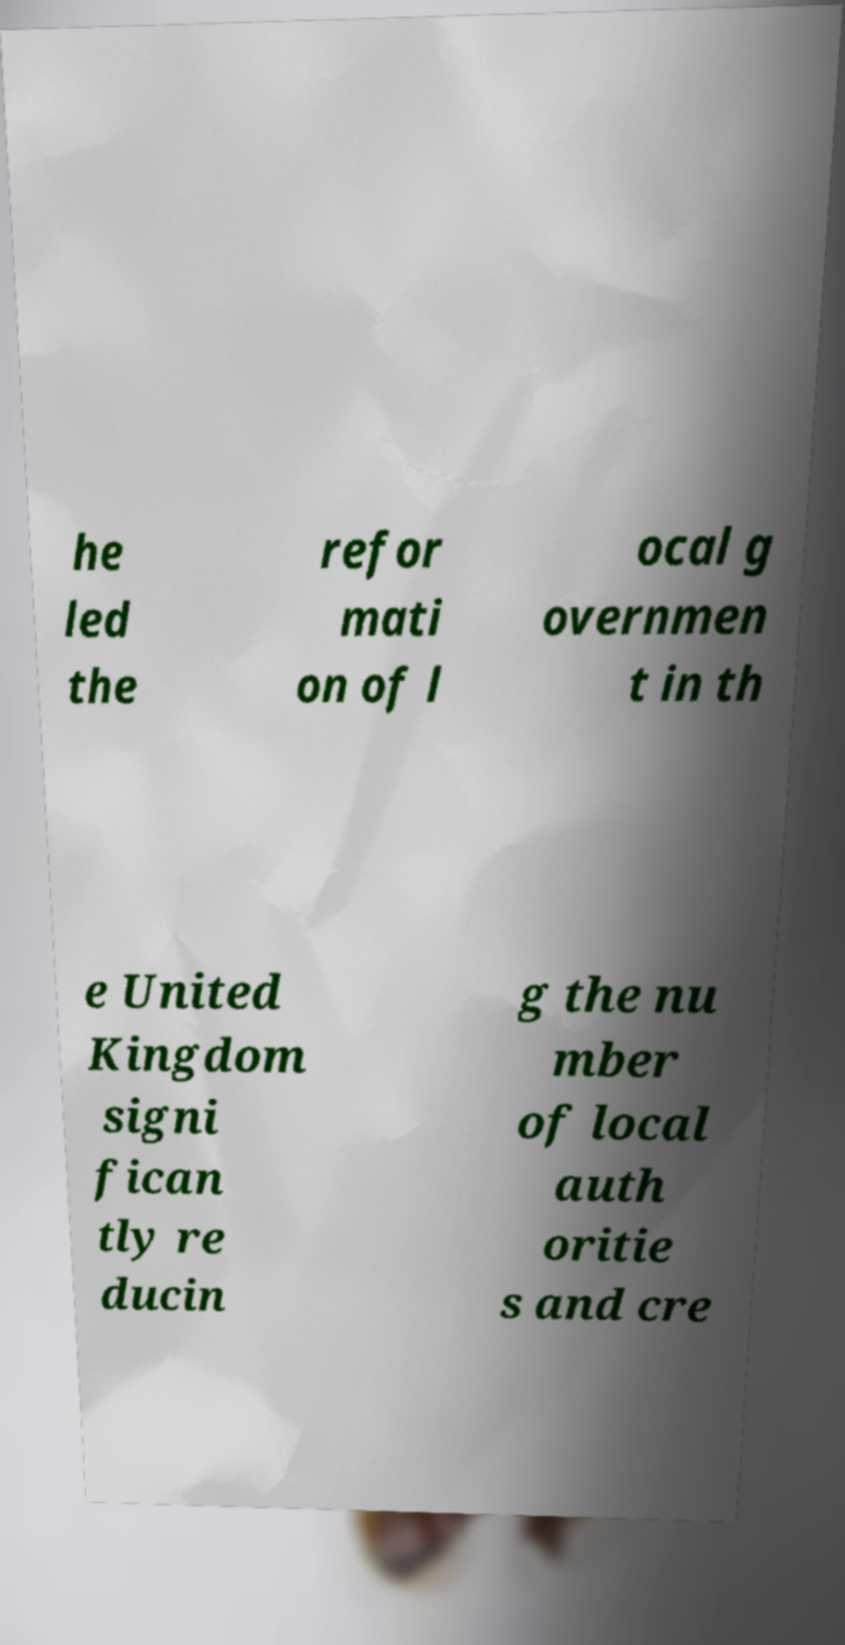I need the written content from this picture converted into text. Can you do that? he led the refor mati on of l ocal g overnmen t in th e United Kingdom signi fican tly re ducin g the nu mber of local auth oritie s and cre 